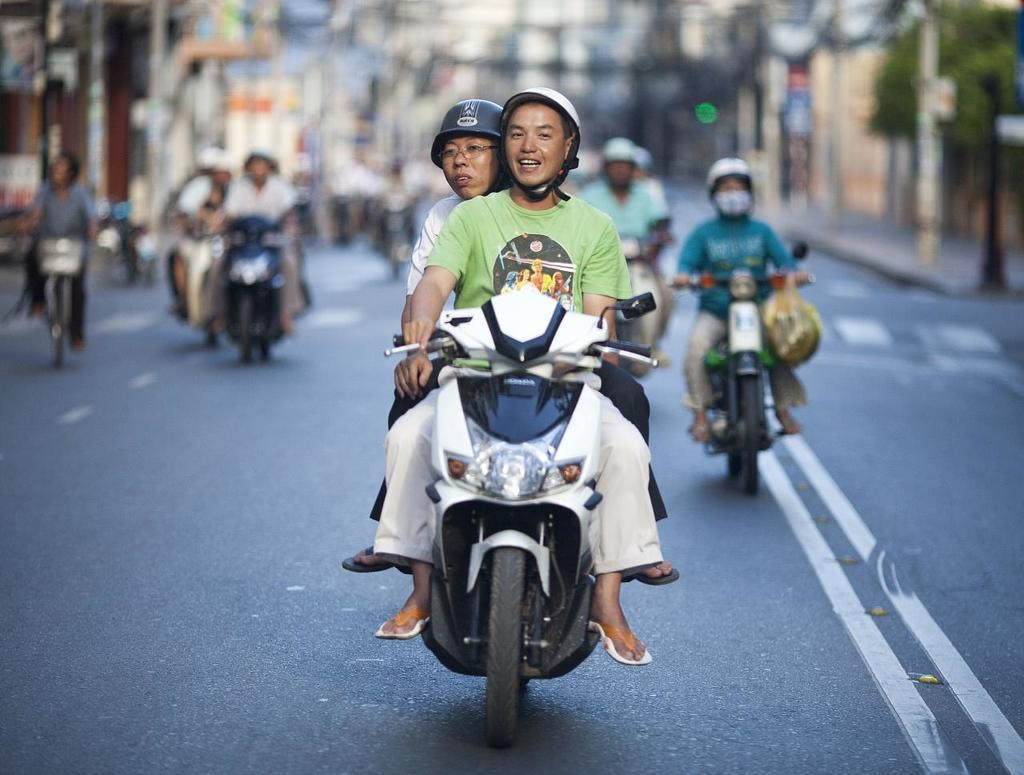How many people are riding a bike in the image? There are two persons riding a bike in the image. What can be seen in the background of the image? There are other people riding bikes in the background. What type of vegetation is visible in the image? There is a tree visible in the image. What object can be seen in the image that is not a bike or a person? There is a pole in the image. What type of butter is being spread on the tree in the image? There is no butter or tree being used for spreading in the image; it features two persons riding a bike and other people riding bikes in the background. 